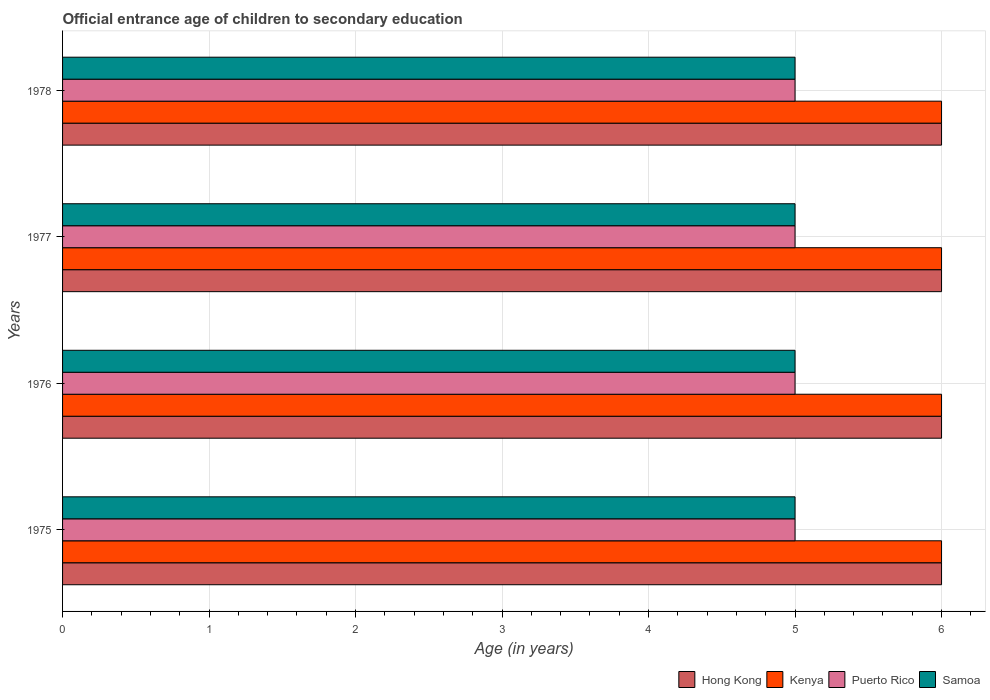How many different coloured bars are there?
Offer a very short reply. 4. How many groups of bars are there?
Offer a terse response. 4. Are the number of bars on each tick of the Y-axis equal?
Keep it short and to the point. Yes. What is the label of the 3rd group of bars from the top?
Provide a short and direct response. 1976. What is the secondary school starting age of children in Hong Kong in 1978?
Your response must be concise. 6. Across all years, what is the maximum secondary school starting age of children in Puerto Rico?
Give a very brief answer. 5. Across all years, what is the minimum secondary school starting age of children in Puerto Rico?
Give a very brief answer. 5. In which year was the secondary school starting age of children in Hong Kong maximum?
Offer a terse response. 1975. In which year was the secondary school starting age of children in Puerto Rico minimum?
Provide a succinct answer. 1975. What is the total secondary school starting age of children in Samoa in the graph?
Your answer should be very brief. 20. What is the difference between the secondary school starting age of children in Kenya in 1976 and that in 1978?
Provide a short and direct response. 0. What is the difference between the secondary school starting age of children in Kenya in 1977 and the secondary school starting age of children in Puerto Rico in 1976?
Offer a very short reply. 1. In the year 1975, what is the difference between the secondary school starting age of children in Kenya and secondary school starting age of children in Puerto Rico?
Make the answer very short. 1. Is the secondary school starting age of children in Samoa in 1976 less than that in 1977?
Provide a short and direct response. No. Is it the case that in every year, the sum of the secondary school starting age of children in Samoa and secondary school starting age of children in Kenya is greater than the sum of secondary school starting age of children in Hong Kong and secondary school starting age of children in Puerto Rico?
Offer a terse response. Yes. What does the 1st bar from the top in 1976 represents?
Make the answer very short. Samoa. What does the 1st bar from the bottom in 1977 represents?
Provide a short and direct response. Hong Kong. Is it the case that in every year, the sum of the secondary school starting age of children in Kenya and secondary school starting age of children in Puerto Rico is greater than the secondary school starting age of children in Samoa?
Make the answer very short. Yes. Does the graph contain grids?
Ensure brevity in your answer.  Yes. What is the title of the graph?
Your response must be concise. Official entrance age of children to secondary education. What is the label or title of the X-axis?
Offer a terse response. Age (in years). What is the label or title of the Y-axis?
Keep it short and to the point. Years. What is the Age (in years) in Kenya in 1975?
Your answer should be compact. 6. What is the Age (in years) in Samoa in 1975?
Offer a very short reply. 5. What is the Age (in years) in Hong Kong in 1976?
Make the answer very short. 6. What is the Age (in years) in Kenya in 1976?
Provide a short and direct response. 6. What is the Age (in years) of Puerto Rico in 1976?
Provide a succinct answer. 5. What is the Age (in years) in Samoa in 1976?
Make the answer very short. 5. What is the Age (in years) in Kenya in 1977?
Offer a very short reply. 6. What is the Age (in years) in Puerto Rico in 1977?
Offer a very short reply. 5. What is the Age (in years) in Samoa in 1977?
Your answer should be very brief. 5. What is the Age (in years) of Hong Kong in 1978?
Make the answer very short. 6. What is the Age (in years) in Kenya in 1978?
Offer a very short reply. 6. What is the Age (in years) of Puerto Rico in 1978?
Offer a terse response. 5. Across all years, what is the maximum Age (in years) in Kenya?
Offer a terse response. 6. Across all years, what is the minimum Age (in years) in Hong Kong?
Ensure brevity in your answer.  6. Across all years, what is the minimum Age (in years) in Kenya?
Offer a very short reply. 6. Across all years, what is the minimum Age (in years) in Puerto Rico?
Give a very brief answer. 5. Across all years, what is the minimum Age (in years) of Samoa?
Your answer should be compact. 5. What is the total Age (in years) of Kenya in the graph?
Provide a succinct answer. 24. What is the total Age (in years) in Samoa in the graph?
Offer a terse response. 20. What is the difference between the Age (in years) of Hong Kong in 1975 and that in 1976?
Provide a succinct answer. 0. What is the difference between the Age (in years) in Kenya in 1975 and that in 1976?
Your response must be concise. 0. What is the difference between the Age (in years) in Puerto Rico in 1975 and that in 1976?
Make the answer very short. 0. What is the difference between the Age (in years) of Samoa in 1975 and that in 1976?
Provide a short and direct response. 0. What is the difference between the Age (in years) of Hong Kong in 1975 and that in 1977?
Provide a succinct answer. 0. What is the difference between the Age (in years) in Samoa in 1975 and that in 1978?
Your response must be concise. 0. What is the difference between the Age (in years) in Puerto Rico in 1976 and that in 1977?
Offer a terse response. 0. What is the difference between the Age (in years) in Hong Kong in 1976 and that in 1978?
Give a very brief answer. 0. What is the difference between the Age (in years) in Puerto Rico in 1976 and that in 1978?
Make the answer very short. 0. What is the difference between the Age (in years) in Samoa in 1976 and that in 1978?
Give a very brief answer. 0. What is the difference between the Age (in years) of Kenya in 1977 and that in 1978?
Offer a terse response. 0. What is the difference between the Age (in years) of Hong Kong in 1975 and the Age (in years) of Kenya in 1976?
Your answer should be very brief. 0. What is the difference between the Age (in years) of Hong Kong in 1975 and the Age (in years) of Puerto Rico in 1976?
Keep it short and to the point. 1. What is the difference between the Age (in years) of Puerto Rico in 1975 and the Age (in years) of Samoa in 1976?
Your answer should be compact. 0. What is the difference between the Age (in years) of Hong Kong in 1975 and the Age (in years) of Kenya in 1977?
Provide a short and direct response. 0. What is the difference between the Age (in years) in Hong Kong in 1975 and the Age (in years) in Puerto Rico in 1977?
Your answer should be very brief. 1. What is the difference between the Age (in years) in Kenya in 1975 and the Age (in years) in Puerto Rico in 1977?
Your answer should be compact. 1. What is the difference between the Age (in years) of Kenya in 1975 and the Age (in years) of Samoa in 1977?
Your answer should be very brief. 1. What is the difference between the Age (in years) of Hong Kong in 1976 and the Age (in years) of Samoa in 1977?
Provide a succinct answer. 1. What is the difference between the Age (in years) in Kenya in 1976 and the Age (in years) in Samoa in 1977?
Provide a short and direct response. 1. What is the difference between the Age (in years) of Hong Kong in 1976 and the Age (in years) of Kenya in 1978?
Provide a short and direct response. 0. What is the difference between the Age (in years) of Hong Kong in 1976 and the Age (in years) of Samoa in 1978?
Keep it short and to the point. 1. What is the difference between the Age (in years) of Puerto Rico in 1976 and the Age (in years) of Samoa in 1978?
Your answer should be compact. 0. What is the difference between the Age (in years) of Hong Kong in 1977 and the Age (in years) of Kenya in 1978?
Give a very brief answer. 0. What is the difference between the Age (in years) in Hong Kong in 1977 and the Age (in years) in Puerto Rico in 1978?
Your answer should be compact. 1. What is the difference between the Age (in years) in Kenya in 1977 and the Age (in years) in Puerto Rico in 1978?
Keep it short and to the point. 1. What is the difference between the Age (in years) in Puerto Rico in 1977 and the Age (in years) in Samoa in 1978?
Offer a terse response. 0. What is the average Age (in years) of Hong Kong per year?
Ensure brevity in your answer.  6. What is the average Age (in years) of Puerto Rico per year?
Give a very brief answer. 5. What is the average Age (in years) of Samoa per year?
Offer a very short reply. 5. In the year 1975, what is the difference between the Age (in years) of Hong Kong and Age (in years) of Samoa?
Your answer should be very brief. 1. In the year 1975, what is the difference between the Age (in years) of Kenya and Age (in years) of Samoa?
Your answer should be very brief. 1. In the year 1976, what is the difference between the Age (in years) of Hong Kong and Age (in years) of Kenya?
Give a very brief answer. 0. In the year 1976, what is the difference between the Age (in years) of Hong Kong and Age (in years) of Samoa?
Your response must be concise. 1. In the year 1976, what is the difference between the Age (in years) of Kenya and Age (in years) of Puerto Rico?
Give a very brief answer. 1. In the year 1977, what is the difference between the Age (in years) in Hong Kong and Age (in years) in Kenya?
Ensure brevity in your answer.  0. In the year 1977, what is the difference between the Age (in years) in Hong Kong and Age (in years) in Puerto Rico?
Give a very brief answer. 1. In the year 1977, what is the difference between the Age (in years) in Hong Kong and Age (in years) in Samoa?
Ensure brevity in your answer.  1. In the year 1977, what is the difference between the Age (in years) of Kenya and Age (in years) of Puerto Rico?
Provide a succinct answer. 1. In the year 1977, what is the difference between the Age (in years) in Kenya and Age (in years) in Samoa?
Ensure brevity in your answer.  1. In the year 1978, what is the difference between the Age (in years) in Hong Kong and Age (in years) in Puerto Rico?
Your response must be concise. 1. In the year 1978, what is the difference between the Age (in years) in Kenya and Age (in years) in Puerto Rico?
Ensure brevity in your answer.  1. What is the ratio of the Age (in years) in Hong Kong in 1975 to that in 1976?
Provide a succinct answer. 1. What is the ratio of the Age (in years) of Samoa in 1975 to that in 1976?
Your response must be concise. 1. What is the ratio of the Age (in years) in Samoa in 1975 to that in 1977?
Your answer should be very brief. 1. What is the ratio of the Age (in years) in Hong Kong in 1975 to that in 1978?
Your answer should be compact. 1. What is the ratio of the Age (in years) in Samoa in 1975 to that in 1978?
Ensure brevity in your answer.  1. What is the ratio of the Age (in years) in Hong Kong in 1976 to that in 1977?
Make the answer very short. 1. What is the ratio of the Age (in years) of Kenya in 1976 to that in 1977?
Ensure brevity in your answer.  1. What is the ratio of the Age (in years) in Samoa in 1976 to that in 1977?
Provide a short and direct response. 1. What is the ratio of the Age (in years) of Hong Kong in 1976 to that in 1978?
Give a very brief answer. 1. What is the ratio of the Age (in years) in Kenya in 1976 to that in 1978?
Keep it short and to the point. 1. What is the ratio of the Age (in years) of Hong Kong in 1977 to that in 1978?
Your answer should be compact. 1. What is the ratio of the Age (in years) in Puerto Rico in 1977 to that in 1978?
Ensure brevity in your answer.  1. What is the difference between the highest and the second highest Age (in years) of Kenya?
Offer a terse response. 0. What is the difference between the highest and the second highest Age (in years) of Puerto Rico?
Ensure brevity in your answer.  0. What is the difference between the highest and the second highest Age (in years) of Samoa?
Make the answer very short. 0. What is the difference between the highest and the lowest Age (in years) in Samoa?
Provide a succinct answer. 0. 